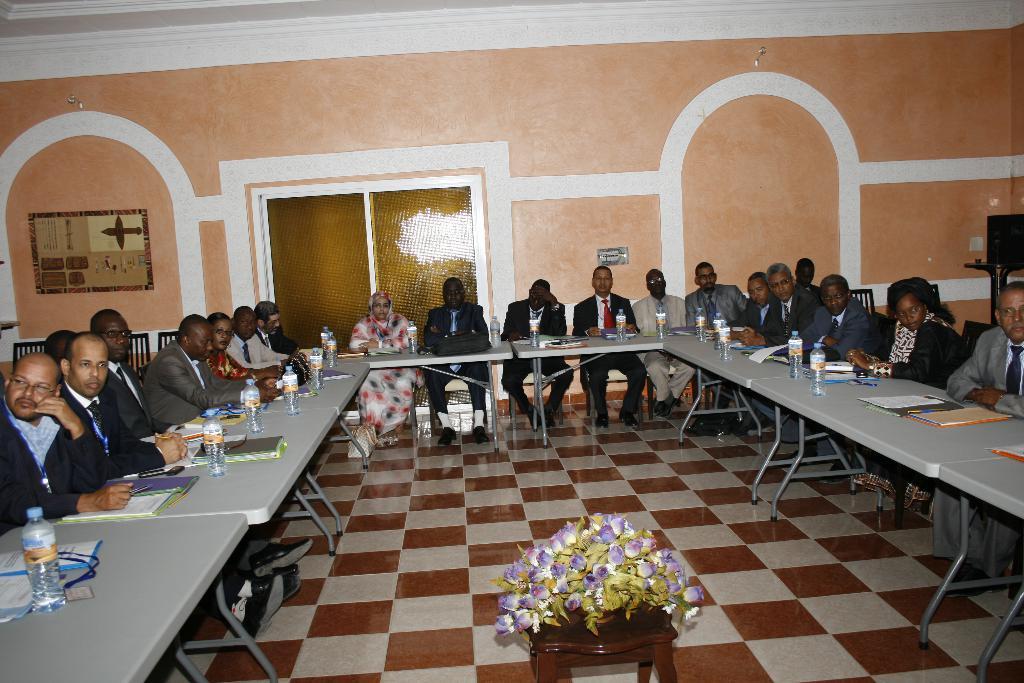Could you give a brief overview of what you see in this image? The image is inside the room. In the image there are group of people sitting on chair in front of a table. On table we can see a identity tag,water bottle,book,paper in background there is a door which is closed and wall which is in pink color. 